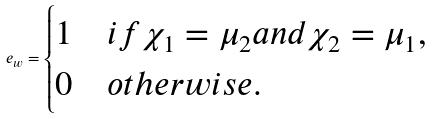<formula> <loc_0><loc_0><loc_500><loc_500>e _ { w } = \begin{cases} 1 & i f \chi _ { 1 } = \mu _ { 2 } a n d \chi _ { 2 } = \mu _ { 1 } , \\ 0 & o t h e r w i s e . \end{cases}</formula> 